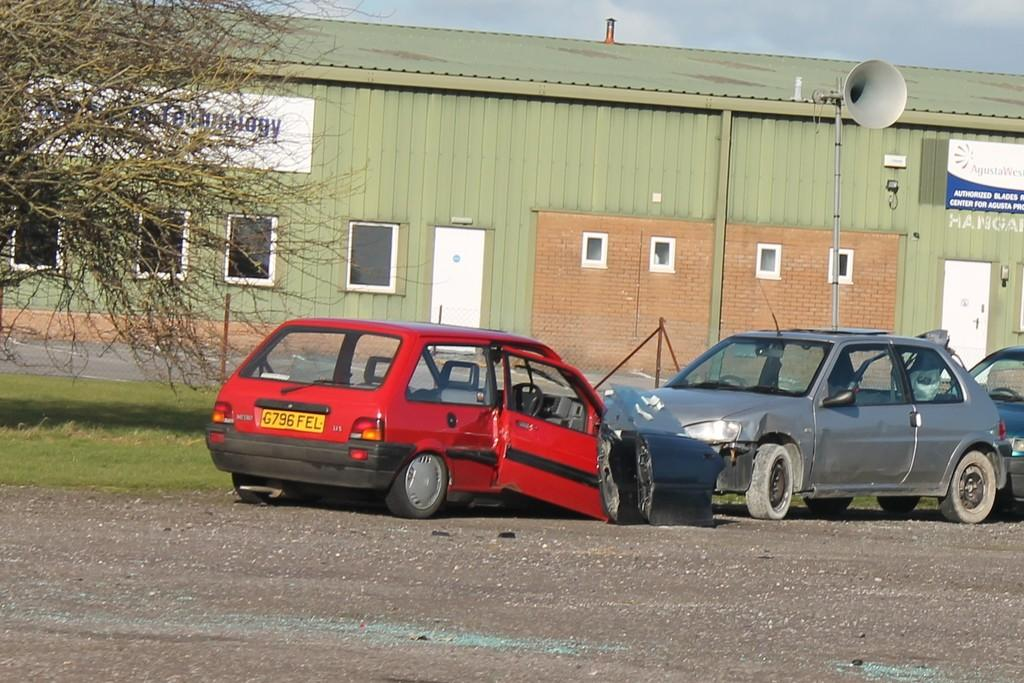What type of vehicles can be seen in the image? There are cars on the ground in the image. What type of vegetation is visible in the image? Grass is visible in the image. What type of structures can be seen in the image? There is a shed in the image. What type of architectural elements are present in the image? Boards, windows, and doors are visible in the image. What is the background of the image? The sky is visible in the background of the image. How does the string help the ants in the image? There are no ants or strings present in the image. What type of change can be seen in the image? The image does not depict any changes; it is a static representation of the scene. 